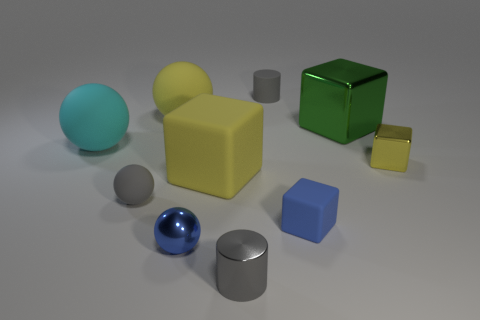Can you describe the texture differences between the objects? Certainly! The objects display a variety of textures: the spheres and the green cube have smooth, shiny surfaces indicative of a reflective material like polished metal. In contrast, the yellow cube and the smaller gray block exhibit more of a matte finish, suggesting a less reflective material like plastic or painted metal. 